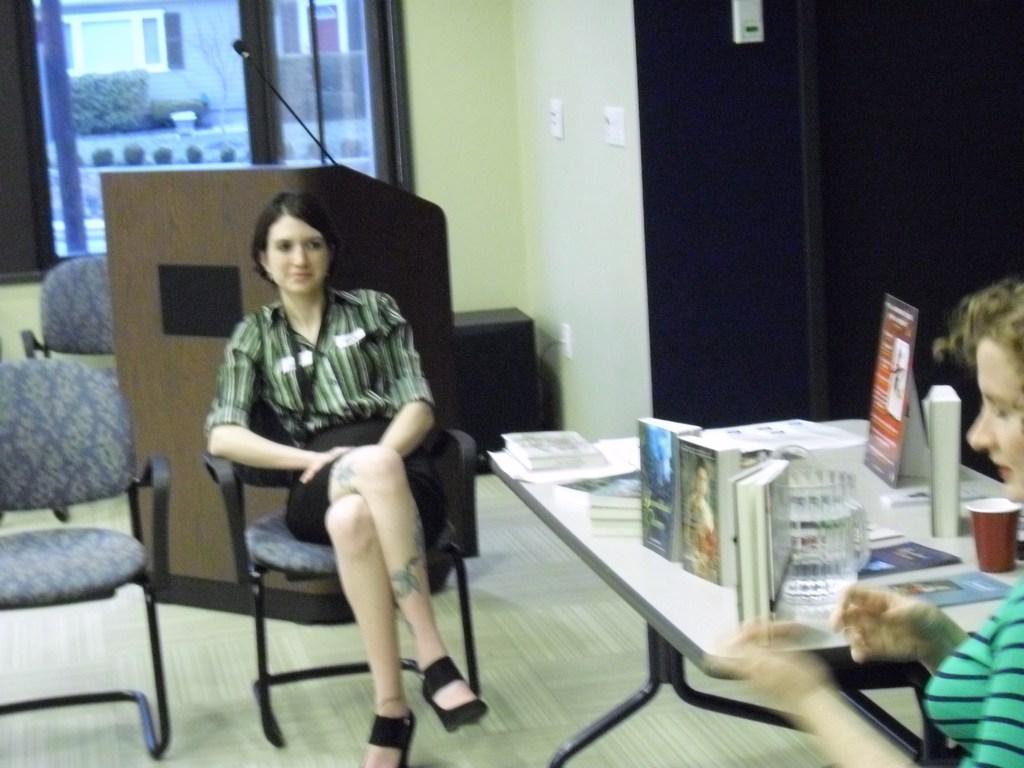Could you give a brief overview of what you see in this image? This is an image clicked inside the room. In this image I can see a woman wearing a shirt and sitting on the chair. On the right side of the image there is another woman. just beside of this woman there is a table. On the table there are some books, bug, papers are there. On the top left of the image I can see a window. 